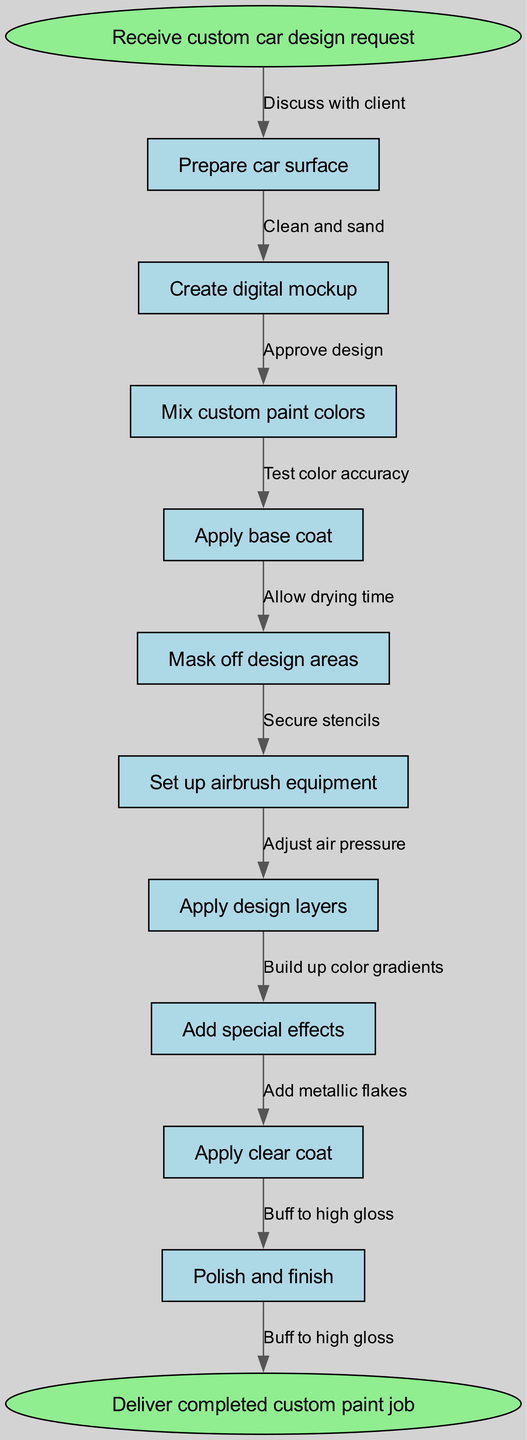What is the starting point of the diagram? The starting point is labeled as “Receive custom car design request”. This is the first node in the flowchart and indicates the initiation of the painting process.
Answer: Receive custom car design request How many process nodes are in the diagram? The diagram contains ten process nodes, which are the actions performed during the airbrush painting process. These nodes include tasks like “Prepare car surface” and “Apply design layers”.
Answer: Ten What is the last step before delivering the completed paint job? The last step before delivery is labeled as “Polish and finish”. This indicates the final process that takes place prior to handing over the completed project.
Answer: Polish and finish What action follows “Mask off design areas”? The action that follows “Mask off design areas” in the flow is “Set up airbrush equipment”. This connection shows that after masking, the next step is preparing the tools needed for painting.
Answer: Set up airbrush equipment What is the first edge in the diagram? The first edge in the diagram connects “Receive custom car design request” to “Prepare car surface”, indicating the first action taken after receiving the design request.
Answer: Discuss with client What is the relationship between "Add special effects" and "Apply clear coat"? The relationship is sequential in nature; “Add special effects” is an action that occurs right before “Apply clear coat”, indicating that special effects are finalized before the clear coat is applied for protection and gloss.
Answer: Sequential How many edges are in the diagram? There are ten edges in the flowchart, each representing the connection and sequence between the ten process nodes and the two terminal nodes.
Answer: Ten What is the action performed after “Create digital mockup”? The action performed after “Create digital mockup” is “Mix custom paint colors”, showing the flow from designing to preparing colors for application.
Answer: Mix custom paint colors What does the edge "Test color accuracy" indicate? The edge “Test color accuracy” indicates that after mixing custom paint colors, it’s essential to ensure that the colors match the client's requirements before proceeding further.
Answer: Ensuring color match 